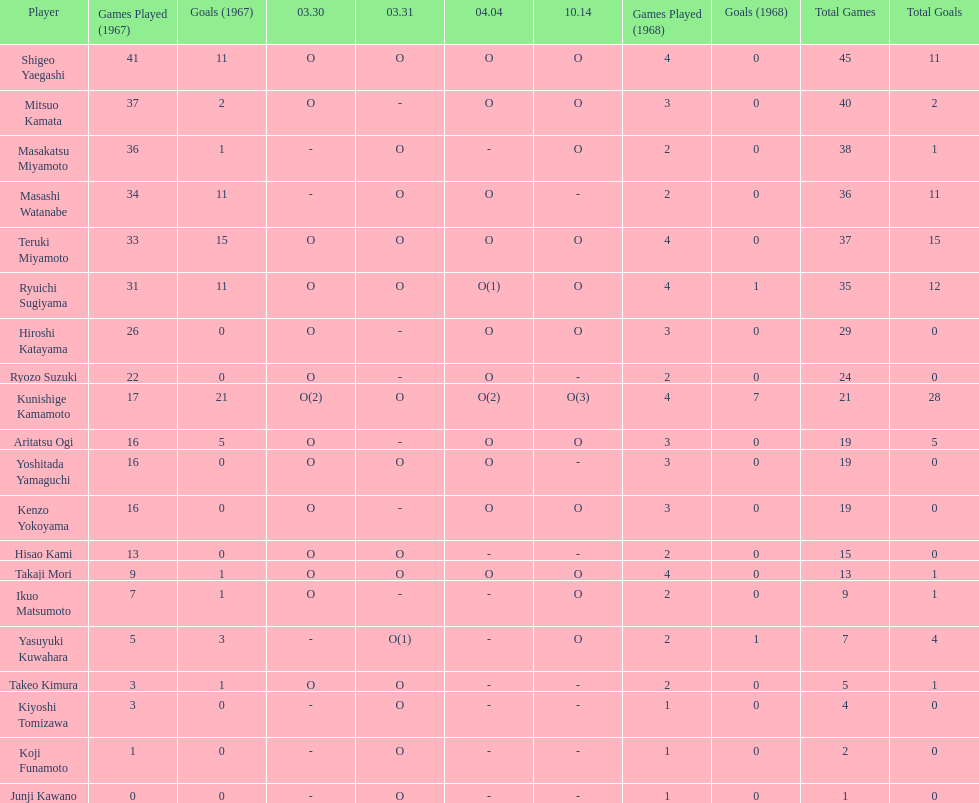Who had more points takaji mori or junji kawano? Takaji Mori. 